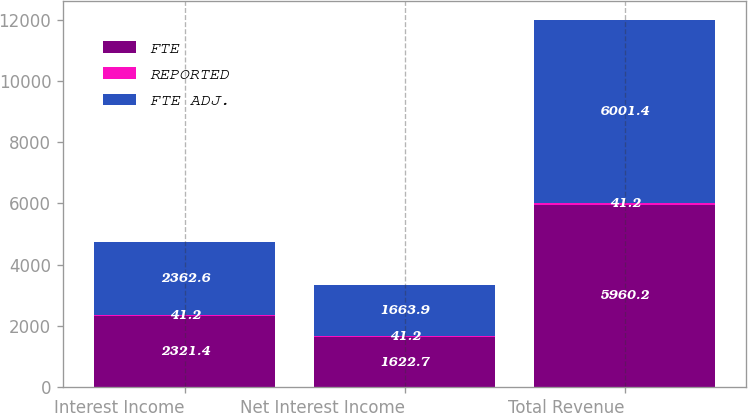Convert chart. <chart><loc_0><loc_0><loc_500><loc_500><stacked_bar_chart><ecel><fcel>Interest Income<fcel>Net Interest Income<fcel>Total Revenue<nl><fcel>FTE<fcel>2321.4<fcel>1622.7<fcel>5960.2<nl><fcel>REPORTED<fcel>41.2<fcel>41.2<fcel>41.2<nl><fcel>FTE ADJ.<fcel>2362.6<fcel>1663.9<fcel>6001.4<nl></chart> 